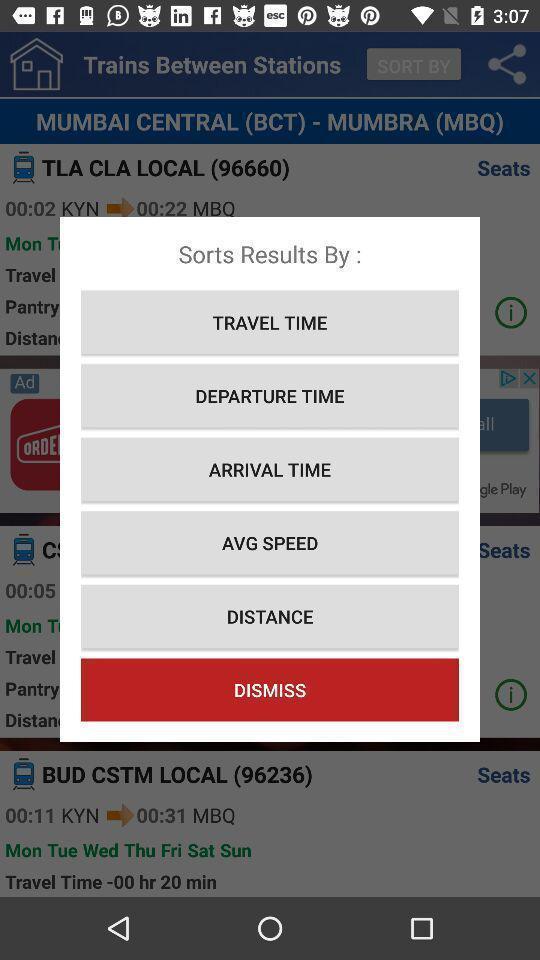Give me a summary of this screen capture. Pop-up to sort the results. 